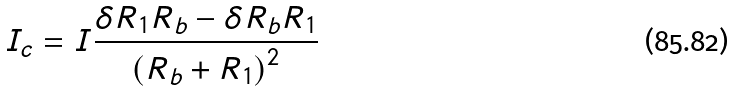Convert formula to latex. <formula><loc_0><loc_0><loc_500><loc_500>I _ { c } = I \frac { \delta R _ { 1 } R _ { b } - \delta R _ { b } R _ { 1 } } { \left ( R _ { b } + R _ { 1 } \right ) ^ { 2 } }</formula> 